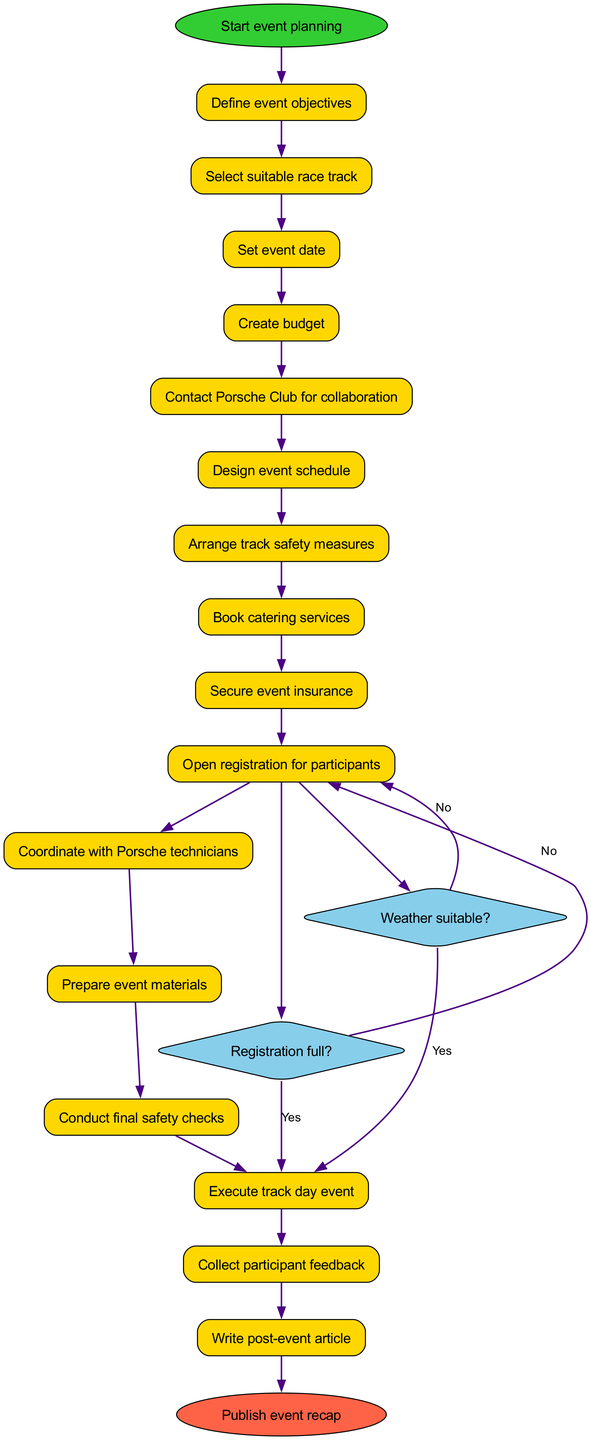What is the initial node in the diagram? The initial node is clearly labeled as "Start event planning," indicating the starting point of the activity flow.
Answer: Start event planning How many decision nodes are present in the diagram? The diagram includes two decision nodes, each representing a condition that affects the flow of the event planning process.
Answer: 2 What happens if the registration is full? According to the diagram, if the registration is full, the flow goes to "Close registration," indicating that no further participant sign-ups can occur at that stage.
Answer: Close registration What activity directly follows "Open registration for participants"? The diagram shows that after "Open registration for participants," the flow branches to a decision node asking "Registration full?" Therefore, "Registration full?" is the next activity in this specific path.
Answer: Registration full? What are the final activities before publishing the event recap? The last activities before reaching the final node "Publish event recap" are "Collect participant feedback" and "Write post-event article," which are necessary steps after the event occurs.
Answer: Collect participant feedback, Write post-event article What condition must be satisfied to proceed with the event? The condition that must be met to proceed with the event is confirmed by the decision node indicating "Weather suitable?" If this is answered positively, the flow continues to "Execute track day event."
Answer: Weather suitable? What occurs if the weather is not suitable? If the weather is deemed not suitable as per the decision node, the next action is to "Reschedule event," which indicates a need to postpone.
Answer: Reschedule event Which activity comes immediately after "Conduct final safety checks"? The activity that directly follows "Conduct final safety checks" is "Execute track day event," highlighting that safety checks are completed before the event.
Answer: Execute track day event 